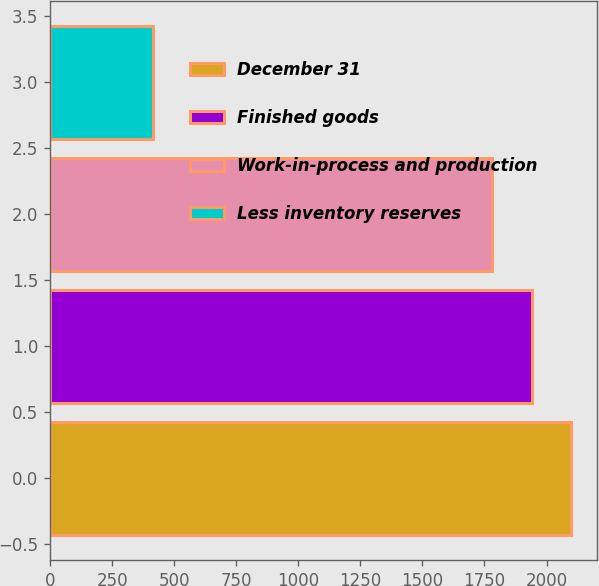Convert chart. <chart><loc_0><loc_0><loc_500><loc_500><bar_chart><fcel>December 31<fcel>Finished goods<fcel>Work-in-process and production<fcel>Less inventory reserves<nl><fcel>2100<fcel>1941<fcel>1782<fcel>416<nl></chart> 